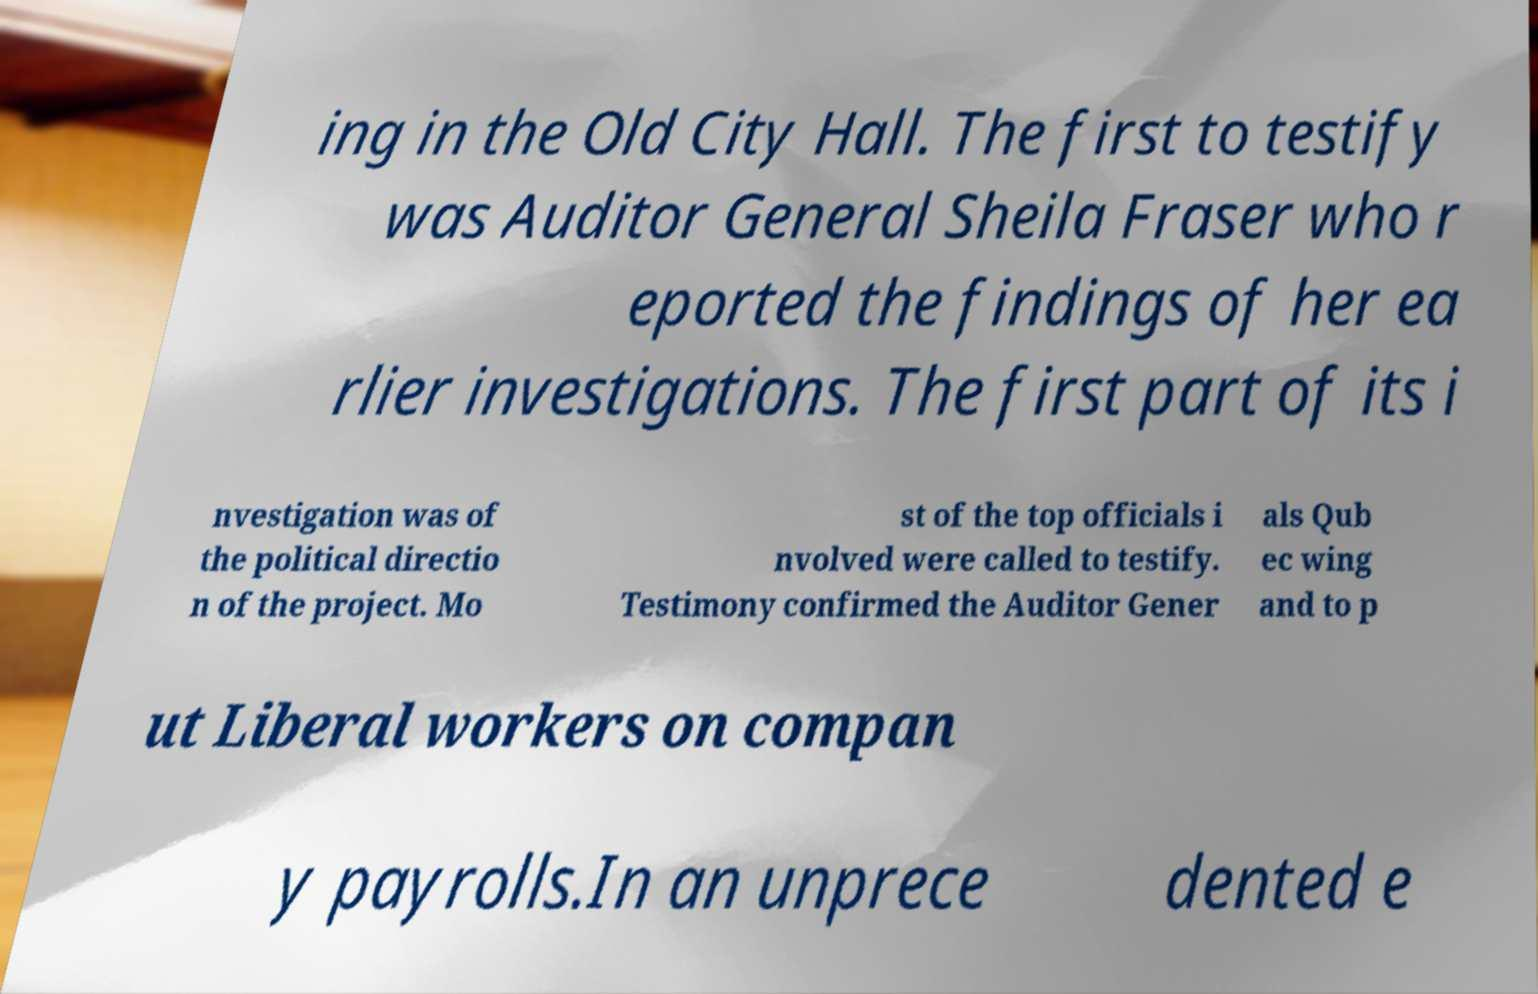What messages or text are displayed in this image? I need them in a readable, typed format. ing in the Old City Hall. The first to testify was Auditor General Sheila Fraser who r eported the findings of her ea rlier investigations. The first part of its i nvestigation was of the political directio n of the project. Mo st of the top officials i nvolved were called to testify. Testimony confirmed the Auditor Gener als Qub ec wing and to p ut Liberal workers on compan y payrolls.In an unprece dented e 